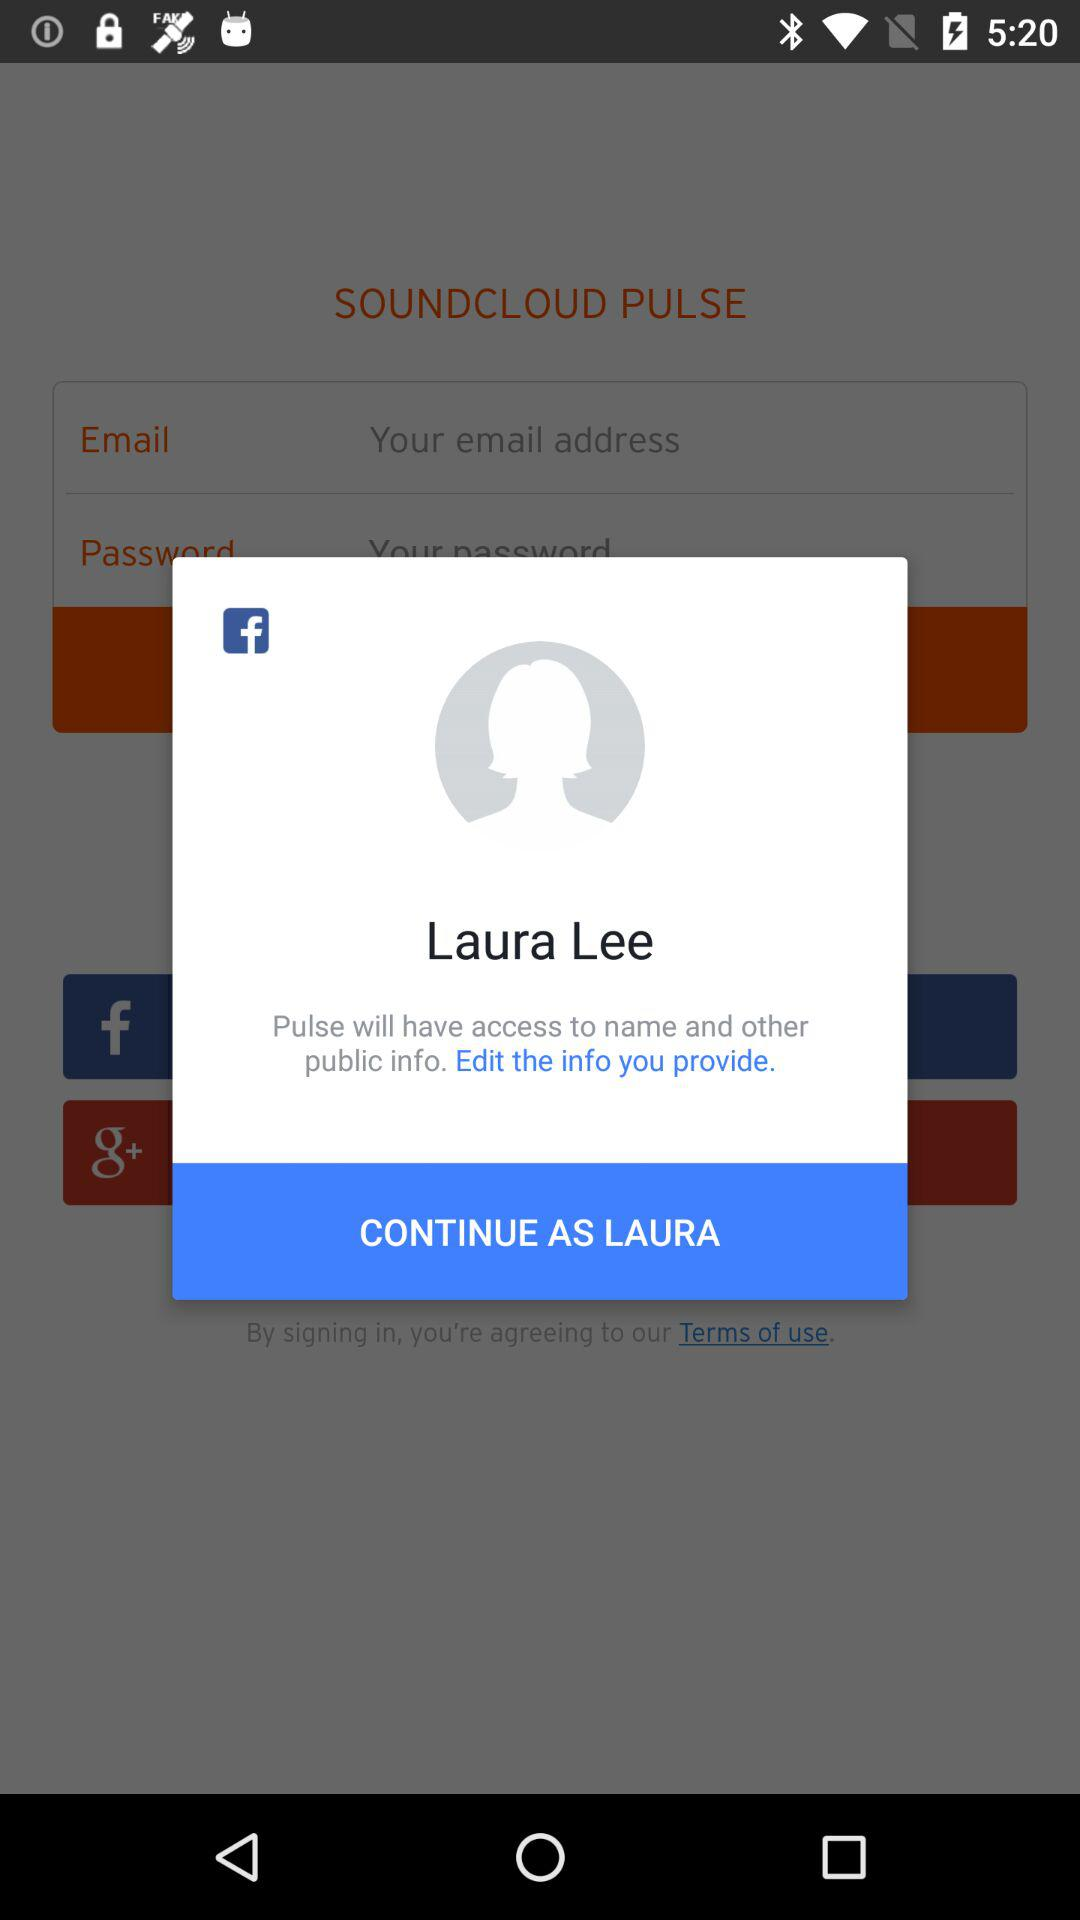What application will have access to the name and other public information? The application that will have access to the name and other profile information is "Pulse". 